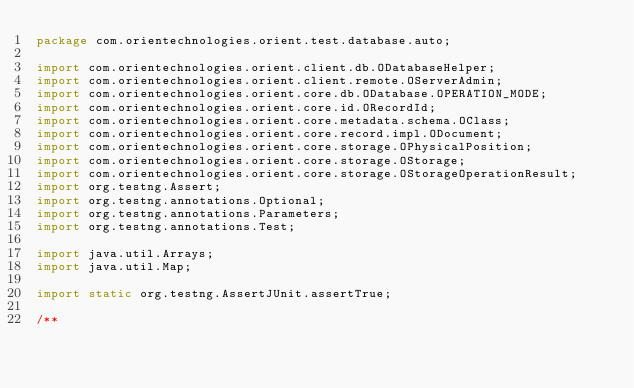Convert code to text. <code><loc_0><loc_0><loc_500><loc_500><_Java_>package com.orientechnologies.orient.test.database.auto;

import com.orientechnologies.orient.client.db.ODatabaseHelper;
import com.orientechnologies.orient.client.remote.OServerAdmin;
import com.orientechnologies.orient.core.db.ODatabase.OPERATION_MODE;
import com.orientechnologies.orient.core.id.ORecordId;
import com.orientechnologies.orient.core.metadata.schema.OClass;
import com.orientechnologies.orient.core.record.impl.ODocument;
import com.orientechnologies.orient.core.storage.OPhysicalPosition;
import com.orientechnologies.orient.core.storage.OStorage;
import com.orientechnologies.orient.core.storage.OStorageOperationResult;
import org.testng.Assert;
import org.testng.annotations.Optional;
import org.testng.annotations.Parameters;
import org.testng.annotations.Test;

import java.util.Arrays;
import java.util.Map;

import static org.testng.AssertJUnit.assertTrue;

/**</code> 